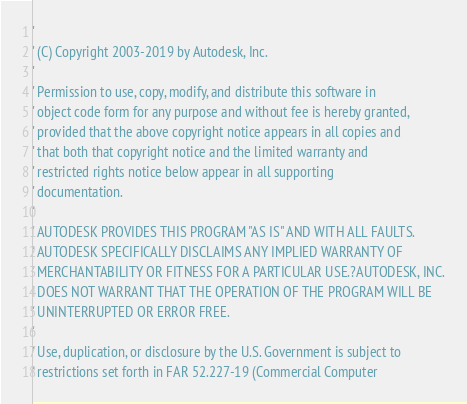Convert code to text. <code><loc_0><loc_0><loc_500><loc_500><_VisualBasic_>'
' (C) Copyright 2003-2019 by Autodesk, Inc.
'
' Permission to use, copy, modify, and distribute this software in
' object code form for any purpose and without fee is hereby granted,
' provided that the above copyright notice appears in all copies and
' that both that copyright notice and the limited warranty and
' restricted rights notice below appear in all supporting
' documentation.
'
' AUTODESK PROVIDES THIS PROGRAM "AS IS" AND WITH ALL FAULTS.
' AUTODESK SPECIFICALLY DISCLAIMS ANY IMPLIED WARRANTY OF
' MERCHANTABILITY OR FITNESS FOR A PARTICULAR USE.?AUTODESK, INC.
' DOES NOT WARRANT THAT THE OPERATION OF THE PROGRAM WILL BE
' UNINTERRUPTED OR ERROR FREE.
'
' Use, duplication, or disclosure by the U.S. Government is subject to
' restrictions set forth in FAR 52.227-19 (Commercial Computer</code> 